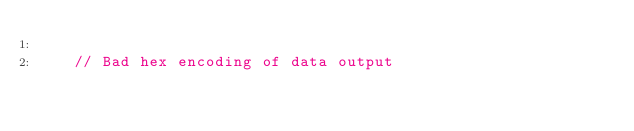<code> <loc_0><loc_0><loc_500><loc_500><_C++_>
    // Bad hex encoding of data output</code> 